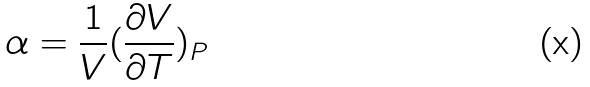Convert formula to latex. <formula><loc_0><loc_0><loc_500><loc_500>\alpha = \frac { 1 } { V } ( \frac { \partial V } { \partial T } ) _ { P }</formula> 